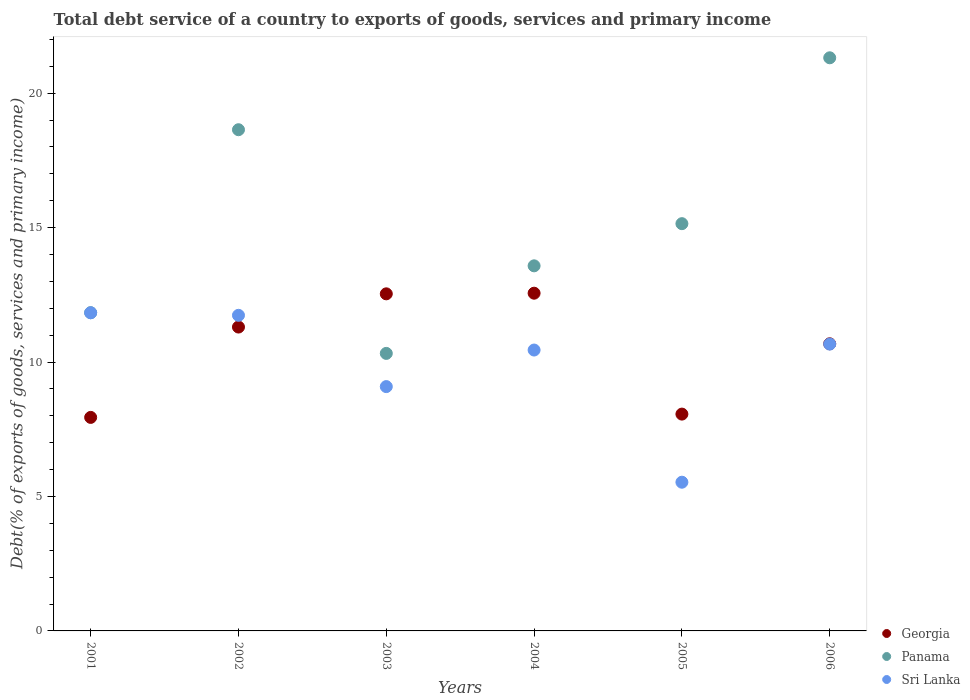How many different coloured dotlines are there?
Keep it short and to the point. 3. Is the number of dotlines equal to the number of legend labels?
Your answer should be compact. Yes. What is the total debt service in Georgia in 2001?
Offer a very short reply. 7.94. Across all years, what is the maximum total debt service in Sri Lanka?
Give a very brief answer. 11.83. Across all years, what is the minimum total debt service in Georgia?
Your response must be concise. 7.94. What is the total total debt service in Sri Lanka in the graph?
Offer a terse response. 59.3. What is the difference between the total debt service in Panama in 2002 and that in 2003?
Your answer should be compact. 8.32. What is the difference between the total debt service in Georgia in 2006 and the total debt service in Sri Lanka in 2004?
Your answer should be compact. 0.23. What is the average total debt service in Georgia per year?
Your answer should be compact. 10.51. In the year 2001, what is the difference between the total debt service in Panama and total debt service in Georgia?
Ensure brevity in your answer.  3.89. In how many years, is the total debt service in Panama greater than 3 %?
Keep it short and to the point. 6. What is the ratio of the total debt service in Georgia in 2002 to that in 2004?
Provide a short and direct response. 0.9. Is the total debt service in Panama in 2004 less than that in 2006?
Your answer should be compact. Yes. What is the difference between the highest and the second highest total debt service in Panama?
Keep it short and to the point. 2.67. What is the difference between the highest and the lowest total debt service in Sri Lanka?
Your response must be concise. 6.3. In how many years, is the total debt service in Sri Lanka greater than the average total debt service in Sri Lanka taken over all years?
Your response must be concise. 4. Is the total debt service in Panama strictly greater than the total debt service in Sri Lanka over the years?
Keep it short and to the point. Yes. Is the total debt service in Sri Lanka strictly less than the total debt service in Panama over the years?
Your answer should be compact. Yes. Does the graph contain any zero values?
Offer a very short reply. No. Does the graph contain grids?
Offer a very short reply. No. Where does the legend appear in the graph?
Make the answer very short. Bottom right. How many legend labels are there?
Ensure brevity in your answer.  3. What is the title of the graph?
Your answer should be compact. Total debt service of a country to exports of goods, services and primary income. What is the label or title of the X-axis?
Offer a terse response. Years. What is the label or title of the Y-axis?
Your answer should be very brief. Debt(% of exports of goods, services and primary income). What is the Debt(% of exports of goods, services and primary income) in Georgia in 2001?
Keep it short and to the point. 7.94. What is the Debt(% of exports of goods, services and primary income) of Panama in 2001?
Offer a terse response. 11.84. What is the Debt(% of exports of goods, services and primary income) in Sri Lanka in 2001?
Make the answer very short. 11.83. What is the Debt(% of exports of goods, services and primary income) of Georgia in 2002?
Your response must be concise. 11.3. What is the Debt(% of exports of goods, services and primary income) of Panama in 2002?
Your answer should be very brief. 18.64. What is the Debt(% of exports of goods, services and primary income) of Sri Lanka in 2002?
Provide a succinct answer. 11.74. What is the Debt(% of exports of goods, services and primary income) in Georgia in 2003?
Keep it short and to the point. 12.54. What is the Debt(% of exports of goods, services and primary income) in Panama in 2003?
Keep it short and to the point. 10.32. What is the Debt(% of exports of goods, services and primary income) in Sri Lanka in 2003?
Your response must be concise. 9.09. What is the Debt(% of exports of goods, services and primary income) in Georgia in 2004?
Keep it short and to the point. 12.56. What is the Debt(% of exports of goods, services and primary income) of Panama in 2004?
Your answer should be compact. 13.58. What is the Debt(% of exports of goods, services and primary income) of Sri Lanka in 2004?
Keep it short and to the point. 10.45. What is the Debt(% of exports of goods, services and primary income) in Georgia in 2005?
Your answer should be very brief. 8.06. What is the Debt(% of exports of goods, services and primary income) in Panama in 2005?
Your response must be concise. 15.15. What is the Debt(% of exports of goods, services and primary income) of Sri Lanka in 2005?
Give a very brief answer. 5.53. What is the Debt(% of exports of goods, services and primary income) in Georgia in 2006?
Provide a succinct answer. 10.68. What is the Debt(% of exports of goods, services and primary income) in Panama in 2006?
Give a very brief answer. 21.31. What is the Debt(% of exports of goods, services and primary income) in Sri Lanka in 2006?
Keep it short and to the point. 10.67. Across all years, what is the maximum Debt(% of exports of goods, services and primary income) of Georgia?
Provide a succinct answer. 12.56. Across all years, what is the maximum Debt(% of exports of goods, services and primary income) in Panama?
Give a very brief answer. 21.31. Across all years, what is the maximum Debt(% of exports of goods, services and primary income) in Sri Lanka?
Your answer should be compact. 11.83. Across all years, what is the minimum Debt(% of exports of goods, services and primary income) in Georgia?
Provide a short and direct response. 7.94. Across all years, what is the minimum Debt(% of exports of goods, services and primary income) in Panama?
Give a very brief answer. 10.32. Across all years, what is the minimum Debt(% of exports of goods, services and primary income) of Sri Lanka?
Give a very brief answer. 5.53. What is the total Debt(% of exports of goods, services and primary income) of Georgia in the graph?
Provide a short and direct response. 63.08. What is the total Debt(% of exports of goods, services and primary income) in Panama in the graph?
Offer a very short reply. 90.83. What is the total Debt(% of exports of goods, services and primary income) in Sri Lanka in the graph?
Give a very brief answer. 59.3. What is the difference between the Debt(% of exports of goods, services and primary income) in Georgia in 2001 and that in 2002?
Keep it short and to the point. -3.36. What is the difference between the Debt(% of exports of goods, services and primary income) of Panama in 2001 and that in 2002?
Offer a very short reply. -6.8. What is the difference between the Debt(% of exports of goods, services and primary income) in Sri Lanka in 2001 and that in 2002?
Provide a succinct answer. 0.09. What is the difference between the Debt(% of exports of goods, services and primary income) in Georgia in 2001 and that in 2003?
Make the answer very short. -4.6. What is the difference between the Debt(% of exports of goods, services and primary income) in Panama in 2001 and that in 2003?
Ensure brevity in your answer.  1.51. What is the difference between the Debt(% of exports of goods, services and primary income) of Sri Lanka in 2001 and that in 2003?
Your answer should be compact. 2.75. What is the difference between the Debt(% of exports of goods, services and primary income) in Georgia in 2001 and that in 2004?
Your answer should be compact. -4.62. What is the difference between the Debt(% of exports of goods, services and primary income) of Panama in 2001 and that in 2004?
Give a very brief answer. -1.74. What is the difference between the Debt(% of exports of goods, services and primary income) in Sri Lanka in 2001 and that in 2004?
Make the answer very short. 1.39. What is the difference between the Debt(% of exports of goods, services and primary income) of Georgia in 2001 and that in 2005?
Provide a short and direct response. -0.12. What is the difference between the Debt(% of exports of goods, services and primary income) in Panama in 2001 and that in 2005?
Your answer should be compact. -3.31. What is the difference between the Debt(% of exports of goods, services and primary income) of Sri Lanka in 2001 and that in 2005?
Your response must be concise. 6.3. What is the difference between the Debt(% of exports of goods, services and primary income) of Georgia in 2001 and that in 2006?
Make the answer very short. -2.74. What is the difference between the Debt(% of exports of goods, services and primary income) of Panama in 2001 and that in 2006?
Offer a very short reply. -9.48. What is the difference between the Debt(% of exports of goods, services and primary income) in Sri Lanka in 2001 and that in 2006?
Your response must be concise. 1.16. What is the difference between the Debt(% of exports of goods, services and primary income) of Georgia in 2002 and that in 2003?
Keep it short and to the point. -1.24. What is the difference between the Debt(% of exports of goods, services and primary income) in Panama in 2002 and that in 2003?
Provide a succinct answer. 8.32. What is the difference between the Debt(% of exports of goods, services and primary income) in Sri Lanka in 2002 and that in 2003?
Your response must be concise. 2.65. What is the difference between the Debt(% of exports of goods, services and primary income) in Georgia in 2002 and that in 2004?
Offer a terse response. -1.26. What is the difference between the Debt(% of exports of goods, services and primary income) of Panama in 2002 and that in 2004?
Offer a terse response. 5.06. What is the difference between the Debt(% of exports of goods, services and primary income) of Sri Lanka in 2002 and that in 2004?
Offer a very short reply. 1.29. What is the difference between the Debt(% of exports of goods, services and primary income) of Georgia in 2002 and that in 2005?
Your response must be concise. 3.24. What is the difference between the Debt(% of exports of goods, services and primary income) of Panama in 2002 and that in 2005?
Offer a terse response. 3.49. What is the difference between the Debt(% of exports of goods, services and primary income) in Sri Lanka in 2002 and that in 2005?
Ensure brevity in your answer.  6.21. What is the difference between the Debt(% of exports of goods, services and primary income) in Georgia in 2002 and that in 2006?
Offer a very short reply. 0.62. What is the difference between the Debt(% of exports of goods, services and primary income) of Panama in 2002 and that in 2006?
Provide a succinct answer. -2.67. What is the difference between the Debt(% of exports of goods, services and primary income) of Sri Lanka in 2002 and that in 2006?
Provide a succinct answer. 1.07. What is the difference between the Debt(% of exports of goods, services and primary income) of Georgia in 2003 and that in 2004?
Keep it short and to the point. -0.02. What is the difference between the Debt(% of exports of goods, services and primary income) of Panama in 2003 and that in 2004?
Provide a succinct answer. -3.26. What is the difference between the Debt(% of exports of goods, services and primary income) of Sri Lanka in 2003 and that in 2004?
Your answer should be compact. -1.36. What is the difference between the Debt(% of exports of goods, services and primary income) of Georgia in 2003 and that in 2005?
Offer a very short reply. 4.47. What is the difference between the Debt(% of exports of goods, services and primary income) of Panama in 2003 and that in 2005?
Provide a succinct answer. -4.82. What is the difference between the Debt(% of exports of goods, services and primary income) in Sri Lanka in 2003 and that in 2005?
Your response must be concise. 3.56. What is the difference between the Debt(% of exports of goods, services and primary income) of Georgia in 2003 and that in 2006?
Give a very brief answer. 1.86. What is the difference between the Debt(% of exports of goods, services and primary income) in Panama in 2003 and that in 2006?
Your response must be concise. -10.99. What is the difference between the Debt(% of exports of goods, services and primary income) of Sri Lanka in 2003 and that in 2006?
Your answer should be compact. -1.58. What is the difference between the Debt(% of exports of goods, services and primary income) of Georgia in 2004 and that in 2005?
Make the answer very short. 4.5. What is the difference between the Debt(% of exports of goods, services and primary income) in Panama in 2004 and that in 2005?
Your answer should be compact. -1.57. What is the difference between the Debt(% of exports of goods, services and primary income) of Sri Lanka in 2004 and that in 2005?
Offer a terse response. 4.92. What is the difference between the Debt(% of exports of goods, services and primary income) in Georgia in 2004 and that in 2006?
Your answer should be compact. 1.88. What is the difference between the Debt(% of exports of goods, services and primary income) of Panama in 2004 and that in 2006?
Provide a succinct answer. -7.74. What is the difference between the Debt(% of exports of goods, services and primary income) of Sri Lanka in 2004 and that in 2006?
Offer a very short reply. -0.22. What is the difference between the Debt(% of exports of goods, services and primary income) in Georgia in 2005 and that in 2006?
Keep it short and to the point. -2.62. What is the difference between the Debt(% of exports of goods, services and primary income) in Panama in 2005 and that in 2006?
Ensure brevity in your answer.  -6.17. What is the difference between the Debt(% of exports of goods, services and primary income) in Sri Lanka in 2005 and that in 2006?
Offer a very short reply. -5.14. What is the difference between the Debt(% of exports of goods, services and primary income) of Georgia in 2001 and the Debt(% of exports of goods, services and primary income) of Panama in 2002?
Give a very brief answer. -10.7. What is the difference between the Debt(% of exports of goods, services and primary income) in Georgia in 2001 and the Debt(% of exports of goods, services and primary income) in Sri Lanka in 2002?
Your answer should be very brief. -3.8. What is the difference between the Debt(% of exports of goods, services and primary income) in Panama in 2001 and the Debt(% of exports of goods, services and primary income) in Sri Lanka in 2002?
Keep it short and to the point. 0.1. What is the difference between the Debt(% of exports of goods, services and primary income) in Georgia in 2001 and the Debt(% of exports of goods, services and primary income) in Panama in 2003?
Give a very brief answer. -2.38. What is the difference between the Debt(% of exports of goods, services and primary income) of Georgia in 2001 and the Debt(% of exports of goods, services and primary income) of Sri Lanka in 2003?
Offer a terse response. -1.15. What is the difference between the Debt(% of exports of goods, services and primary income) of Panama in 2001 and the Debt(% of exports of goods, services and primary income) of Sri Lanka in 2003?
Ensure brevity in your answer.  2.75. What is the difference between the Debt(% of exports of goods, services and primary income) of Georgia in 2001 and the Debt(% of exports of goods, services and primary income) of Panama in 2004?
Keep it short and to the point. -5.64. What is the difference between the Debt(% of exports of goods, services and primary income) in Georgia in 2001 and the Debt(% of exports of goods, services and primary income) in Sri Lanka in 2004?
Provide a short and direct response. -2.51. What is the difference between the Debt(% of exports of goods, services and primary income) of Panama in 2001 and the Debt(% of exports of goods, services and primary income) of Sri Lanka in 2004?
Provide a succinct answer. 1.39. What is the difference between the Debt(% of exports of goods, services and primary income) in Georgia in 2001 and the Debt(% of exports of goods, services and primary income) in Panama in 2005?
Your answer should be compact. -7.2. What is the difference between the Debt(% of exports of goods, services and primary income) of Georgia in 2001 and the Debt(% of exports of goods, services and primary income) of Sri Lanka in 2005?
Ensure brevity in your answer.  2.41. What is the difference between the Debt(% of exports of goods, services and primary income) in Panama in 2001 and the Debt(% of exports of goods, services and primary income) in Sri Lanka in 2005?
Your response must be concise. 6.3. What is the difference between the Debt(% of exports of goods, services and primary income) of Georgia in 2001 and the Debt(% of exports of goods, services and primary income) of Panama in 2006?
Your answer should be very brief. -13.37. What is the difference between the Debt(% of exports of goods, services and primary income) of Georgia in 2001 and the Debt(% of exports of goods, services and primary income) of Sri Lanka in 2006?
Provide a short and direct response. -2.73. What is the difference between the Debt(% of exports of goods, services and primary income) in Panama in 2001 and the Debt(% of exports of goods, services and primary income) in Sri Lanka in 2006?
Give a very brief answer. 1.17. What is the difference between the Debt(% of exports of goods, services and primary income) of Georgia in 2002 and the Debt(% of exports of goods, services and primary income) of Panama in 2003?
Ensure brevity in your answer.  0.98. What is the difference between the Debt(% of exports of goods, services and primary income) in Georgia in 2002 and the Debt(% of exports of goods, services and primary income) in Sri Lanka in 2003?
Make the answer very short. 2.21. What is the difference between the Debt(% of exports of goods, services and primary income) of Panama in 2002 and the Debt(% of exports of goods, services and primary income) of Sri Lanka in 2003?
Provide a short and direct response. 9.55. What is the difference between the Debt(% of exports of goods, services and primary income) in Georgia in 2002 and the Debt(% of exports of goods, services and primary income) in Panama in 2004?
Provide a succinct answer. -2.28. What is the difference between the Debt(% of exports of goods, services and primary income) in Georgia in 2002 and the Debt(% of exports of goods, services and primary income) in Sri Lanka in 2004?
Make the answer very short. 0.85. What is the difference between the Debt(% of exports of goods, services and primary income) in Panama in 2002 and the Debt(% of exports of goods, services and primary income) in Sri Lanka in 2004?
Your answer should be compact. 8.19. What is the difference between the Debt(% of exports of goods, services and primary income) of Georgia in 2002 and the Debt(% of exports of goods, services and primary income) of Panama in 2005?
Provide a succinct answer. -3.85. What is the difference between the Debt(% of exports of goods, services and primary income) in Georgia in 2002 and the Debt(% of exports of goods, services and primary income) in Sri Lanka in 2005?
Ensure brevity in your answer.  5.77. What is the difference between the Debt(% of exports of goods, services and primary income) in Panama in 2002 and the Debt(% of exports of goods, services and primary income) in Sri Lanka in 2005?
Give a very brief answer. 13.11. What is the difference between the Debt(% of exports of goods, services and primary income) of Georgia in 2002 and the Debt(% of exports of goods, services and primary income) of Panama in 2006?
Provide a succinct answer. -10.01. What is the difference between the Debt(% of exports of goods, services and primary income) in Georgia in 2002 and the Debt(% of exports of goods, services and primary income) in Sri Lanka in 2006?
Your response must be concise. 0.63. What is the difference between the Debt(% of exports of goods, services and primary income) of Panama in 2002 and the Debt(% of exports of goods, services and primary income) of Sri Lanka in 2006?
Provide a short and direct response. 7.97. What is the difference between the Debt(% of exports of goods, services and primary income) in Georgia in 2003 and the Debt(% of exports of goods, services and primary income) in Panama in 2004?
Make the answer very short. -1.04. What is the difference between the Debt(% of exports of goods, services and primary income) in Georgia in 2003 and the Debt(% of exports of goods, services and primary income) in Sri Lanka in 2004?
Provide a succinct answer. 2.09. What is the difference between the Debt(% of exports of goods, services and primary income) of Panama in 2003 and the Debt(% of exports of goods, services and primary income) of Sri Lanka in 2004?
Your answer should be compact. -0.13. What is the difference between the Debt(% of exports of goods, services and primary income) of Georgia in 2003 and the Debt(% of exports of goods, services and primary income) of Panama in 2005?
Your answer should be compact. -2.61. What is the difference between the Debt(% of exports of goods, services and primary income) in Georgia in 2003 and the Debt(% of exports of goods, services and primary income) in Sri Lanka in 2005?
Your answer should be very brief. 7.01. What is the difference between the Debt(% of exports of goods, services and primary income) in Panama in 2003 and the Debt(% of exports of goods, services and primary income) in Sri Lanka in 2005?
Offer a terse response. 4.79. What is the difference between the Debt(% of exports of goods, services and primary income) of Georgia in 2003 and the Debt(% of exports of goods, services and primary income) of Panama in 2006?
Keep it short and to the point. -8.78. What is the difference between the Debt(% of exports of goods, services and primary income) of Georgia in 2003 and the Debt(% of exports of goods, services and primary income) of Sri Lanka in 2006?
Provide a short and direct response. 1.87. What is the difference between the Debt(% of exports of goods, services and primary income) of Panama in 2003 and the Debt(% of exports of goods, services and primary income) of Sri Lanka in 2006?
Offer a terse response. -0.35. What is the difference between the Debt(% of exports of goods, services and primary income) of Georgia in 2004 and the Debt(% of exports of goods, services and primary income) of Panama in 2005?
Provide a succinct answer. -2.59. What is the difference between the Debt(% of exports of goods, services and primary income) in Georgia in 2004 and the Debt(% of exports of goods, services and primary income) in Sri Lanka in 2005?
Keep it short and to the point. 7.03. What is the difference between the Debt(% of exports of goods, services and primary income) of Panama in 2004 and the Debt(% of exports of goods, services and primary income) of Sri Lanka in 2005?
Provide a short and direct response. 8.05. What is the difference between the Debt(% of exports of goods, services and primary income) in Georgia in 2004 and the Debt(% of exports of goods, services and primary income) in Panama in 2006?
Your response must be concise. -8.75. What is the difference between the Debt(% of exports of goods, services and primary income) in Georgia in 2004 and the Debt(% of exports of goods, services and primary income) in Sri Lanka in 2006?
Offer a terse response. 1.89. What is the difference between the Debt(% of exports of goods, services and primary income) of Panama in 2004 and the Debt(% of exports of goods, services and primary income) of Sri Lanka in 2006?
Give a very brief answer. 2.91. What is the difference between the Debt(% of exports of goods, services and primary income) of Georgia in 2005 and the Debt(% of exports of goods, services and primary income) of Panama in 2006?
Offer a terse response. -13.25. What is the difference between the Debt(% of exports of goods, services and primary income) of Georgia in 2005 and the Debt(% of exports of goods, services and primary income) of Sri Lanka in 2006?
Offer a very short reply. -2.6. What is the difference between the Debt(% of exports of goods, services and primary income) of Panama in 2005 and the Debt(% of exports of goods, services and primary income) of Sri Lanka in 2006?
Ensure brevity in your answer.  4.48. What is the average Debt(% of exports of goods, services and primary income) of Georgia per year?
Your response must be concise. 10.51. What is the average Debt(% of exports of goods, services and primary income) in Panama per year?
Provide a short and direct response. 15.14. What is the average Debt(% of exports of goods, services and primary income) of Sri Lanka per year?
Offer a terse response. 9.88. In the year 2001, what is the difference between the Debt(% of exports of goods, services and primary income) in Georgia and Debt(% of exports of goods, services and primary income) in Panama?
Provide a short and direct response. -3.89. In the year 2001, what is the difference between the Debt(% of exports of goods, services and primary income) of Georgia and Debt(% of exports of goods, services and primary income) of Sri Lanka?
Offer a very short reply. -3.89. In the year 2001, what is the difference between the Debt(% of exports of goods, services and primary income) in Panama and Debt(% of exports of goods, services and primary income) in Sri Lanka?
Your answer should be very brief. 0. In the year 2002, what is the difference between the Debt(% of exports of goods, services and primary income) of Georgia and Debt(% of exports of goods, services and primary income) of Panama?
Offer a terse response. -7.34. In the year 2002, what is the difference between the Debt(% of exports of goods, services and primary income) of Georgia and Debt(% of exports of goods, services and primary income) of Sri Lanka?
Your response must be concise. -0.44. In the year 2002, what is the difference between the Debt(% of exports of goods, services and primary income) in Panama and Debt(% of exports of goods, services and primary income) in Sri Lanka?
Give a very brief answer. 6.9. In the year 2003, what is the difference between the Debt(% of exports of goods, services and primary income) of Georgia and Debt(% of exports of goods, services and primary income) of Panama?
Your answer should be very brief. 2.22. In the year 2003, what is the difference between the Debt(% of exports of goods, services and primary income) of Georgia and Debt(% of exports of goods, services and primary income) of Sri Lanka?
Give a very brief answer. 3.45. In the year 2003, what is the difference between the Debt(% of exports of goods, services and primary income) of Panama and Debt(% of exports of goods, services and primary income) of Sri Lanka?
Provide a short and direct response. 1.23. In the year 2004, what is the difference between the Debt(% of exports of goods, services and primary income) of Georgia and Debt(% of exports of goods, services and primary income) of Panama?
Keep it short and to the point. -1.02. In the year 2004, what is the difference between the Debt(% of exports of goods, services and primary income) of Georgia and Debt(% of exports of goods, services and primary income) of Sri Lanka?
Offer a terse response. 2.11. In the year 2004, what is the difference between the Debt(% of exports of goods, services and primary income) of Panama and Debt(% of exports of goods, services and primary income) of Sri Lanka?
Your response must be concise. 3.13. In the year 2005, what is the difference between the Debt(% of exports of goods, services and primary income) in Georgia and Debt(% of exports of goods, services and primary income) in Panama?
Provide a succinct answer. -7.08. In the year 2005, what is the difference between the Debt(% of exports of goods, services and primary income) of Georgia and Debt(% of exports of goods, services and primary income) of Sri Lanka?
Your answer should be compact. 2.53. In the year 2005, what is the difference between the Debt(% of exports of goods, services and primary income) in Panama and Debt(% of exports of goods, services and primary income) in Sri Lanka?
Provide a short and direct response. 9.62. In the year 2006, what is the difference between the Debt(% of exports of goods, services and primary income) of Georgia and Debt(% of exports of goods, services and primary income) of Panama?
Give a very brief answer. -10.64. In the year 2006, what is the difference between the Debt(% of exports of goods, services and primary income) in Georgia and Debt(% of exports of goods, services and primary income) in Sri Lanka?
Keep it short and to the point. 0.01. In the year 2006, what is the difference between the Debt(% of exports of goods, services and primary income) of Panama and Debt(% of exports of goods, services and primary income) of Sri Lanka?
Your answer should be very brief. 10.65. What is the ratio of the Debt(% of exports of goods, services and primary income) in Georgia in 2001 to that in 2002?
Your answer should be compact. 0.7. What is the ratio of the Debt(% of exports of goods, services and primary income) in Panama in 2001 to that in 2002?
Provide a short and direct response. 0.63. What is the ratio of the Debt(% of exports of goods, services and primary income) of Sri Lanka in 2001 to that in 2002?
Keep it short and to the point. 1.01. What is the ratio of the Debt(% of exports of goods, services and primary income) of Georgia in 2001 to that in 2003?
Ensure brevity in your answer.  0.63. What is the ratio of the Debt(% of exports of goods, services and primary income) of Panama in 2001 to that in 2003?
Keep it short and to the point. 1.15. What is the ratio of the Debt(% of exports of goods, services and primary income) in Sri Lanka in 2001 to that in 2003?
Provide a succinct answer. 1.3. What is the ratio of the Debt(% of exports of goods, services and primary income) of Georgia in 2001 to that in 2004?
Give a very brief answer. 0.63. What is the ratio of the Debt(% of exports of goods, services and primary income) of Panama in 2001 to that in 2004?
Offer a terse response. 0.87. What is the ratio of the Debt(% of exports of goods, services and primary income) in Sri Lanka in 2001 to that in 2004?
Your answer should be compact. 1.13. What is the ratio of the Debt(% of exports of goods, services and primary income) in Georgia in 2001 to that in 2005?
Your answer should be compact. 0.98. What is the ratio of the Debt(% of exports of goods, services and primary income) in Panama in 2001 to that in 2005?
Give a very brief answer. 0.78. What is the ratio of the Debt(% of exports of goods, services and primary income) of Sri Lanka in 2001 to that in 2005?
Offer a terse response. 2.14. What is the ratio of the Debt(% of exports of goods, services and primary income) in Georgia in 2001 to that in 2006?
Provide a short and direct response. 0.74. What is the ratio of the Debt(% of exports of goods, services and primary income) in Panama in 2001 to that in 2006?
Offer a terse response. 0.56. What is the ratio of the Debt(% of exports of goods, services and primary income) of Sri Lanka in 2001 to that in 2006?
Provide a short and direct response. 1.11. What is the ratio of the Debt(% of exports of goods, services and primary income) of Georgia in 2002 to that in 2003?
Offer a terse response. 0.9. What is the ratio of the Debt(% of exports of goods, services and primary income) in Panama in 2002 to that in 2003?
Offer a terse response. 1.81. What is the ratio of the Debt(% of exports of goods, services and primary income) of Sri Lanka in 2002 to that in 2003?
Provide a short and direct response. 1.29. What is the ratio of the Debt(% of exports of goods, services and primary income) of Georgia in 2002 to that in 2004?
Your answer should be compact. 0.9. What is the ratio of the Debt(% of exports of goods, services and primary income) in Panama in 2002 to that in 2004?
Make the answer very short. 1.37. What is the ratio of the Debt(% of exports of goods, services and primary income) in Sri Lanka in 2002 to that in 2004?
Provide a short and direct response. 1.12. What is the ratio of the Debt(% of exports of goods, services and primary income) in Georgia in 2002 to that in 2005?
Give a very brief answer. 1.4. What is the ratio of the Debt(% of exports of goods, services and primary income) of Panama in 2002 to that in 2005?
Keep it short and to the point. 1.23. What is the ratio of the Debt(% of exports of goods, services and primary income) in Sri Lanka in 2002 to that in 2005?
Provide a succinct answer. 2.12. What is the ratio of the Debt(% of exports of goods, services and primary income) of Georgia in 2002 to that in 2006?
Ensure brevity in your answer.  1.06. What is the ratio of the Debt(% of exports of goods, services and primary income) in Panama in 2002 to that in 2006?
Your response must be concise. 0.87. What is the ratio of the Debt(% of exports of goods, services and primary income) of Sri Lanka in 2002 to that in 2006?
Make the answer very short. 1.1. What is the ratio of the Debt(% of exports of goods, services and primary income) of Panama in 2003 to that in 2004?
Provide a succinct answer. 0.76. What is the ratio of the Debt(% of exports of goods, services and primary income) in Sri Lanka in 2003 to that in 2004?
Provide a short and direct response. 0.87. What is the ratio of the Debt(% of exports of goods, services and primary income) of Georgia in 2003 to that in 2005?
Make the answer very short. 1.55. What is the ratio of the Debt(% of exports of goods, services and primary income) in Panama in 2003 to that in 2005?
Offer a terse response. 0.68. What is the ratio of the Debt(% of exports of goods, services and primary income) of Sri Lanka in 2003 to that in 2005?
Give a very brief answer. 1.64. What is the ratio of the Debt(% of exports of goods, services and primary income) of Georgia in 2003 to that in 2006?
Your answer should be compact. 1.17. What is the ratio of the Debt(% of exports of goods, services and primary income) of Panama in 2003 to that in 2006?
Give a very brief answer. 0.48. What is the ratio of the Debt(% of exports of goods, services and primary income) in Sri Lanka in 2003 to that in 2006?
Offer a terse response. 0.85. What is the ratio of the Debt(% of exports of goods, services and primary income) in Georgia in 2004 to that in 2005?
Keep it short and to the point. 1.56. What is the ratio of the Debt(% of exports of goods, services and primary income) of Panama in 2004 to that in 2005?
Keep it short and to the point. 0.9. What is the ratio of the Debt(% of exports of goods, services and primary income) of Sri Lanka in 2004 to that in 2005?
Make the answer very short. 1.89. What is the ratio of the Debt(% of exports of goods, services and primary income) of Georgia in 2004 to that in 2006?
Your response must be concise. 1.18. What is the ratio of the Debt(% of exports of goods, services and primary income) in Panama in 2004 to that in 2006?
Make the answer very short. 0.64. What is the ratio of the Debt(% of exports of goods, services and primary income) of Sri Lanka in 2004 to that in 2006?
Provide a succinct answer. 0.98. What is the ratio of the Debt(% of exports of goods, services and primary income) in Georgia in 2005 to that in 2006?
Your answer should be compact. 0.76. What is the ratio of the Debt(% of exports of goods, services and primary income) in Panama in 2005 to that in 2006?
Your answer should be compact. 0.71. What is the ratio of the Debt(% of exports of goods, services and primary income) of Sri Lanka in 2005 to that in 2006?
Ensure brevity in your answer.  0.52. What is the difference between the highest and the second highest Debt(% of exports of goods, services and primary income) in Georgia?
Offer a very short reply. 0.02. What is the difference between the highest and the second highest Debt(% of exports of goods, services and primary income) of Panama?
Provide a succinct answer. 2.67. What is the difference between the highest and the second highest Debt(% of exports of goods, services and primary income) in Sri Lanka?
Your response must be concise. 0.09. What is the difference between the highest and the lowest Debt(% of exports of goods, services and primary income) of Georgia?
Ensure brevity in your answer.  4.62. What is the difference between the highest and the lowest Debt(% of exports of goods, services and primary income) in Panama?
Your answer should be very brief. 10.99. What is the difference between the highest and the lowest Debt(% of exports of goods, services and primary income) of Sri Lanka?
Offer a very short reply. 6.3. 